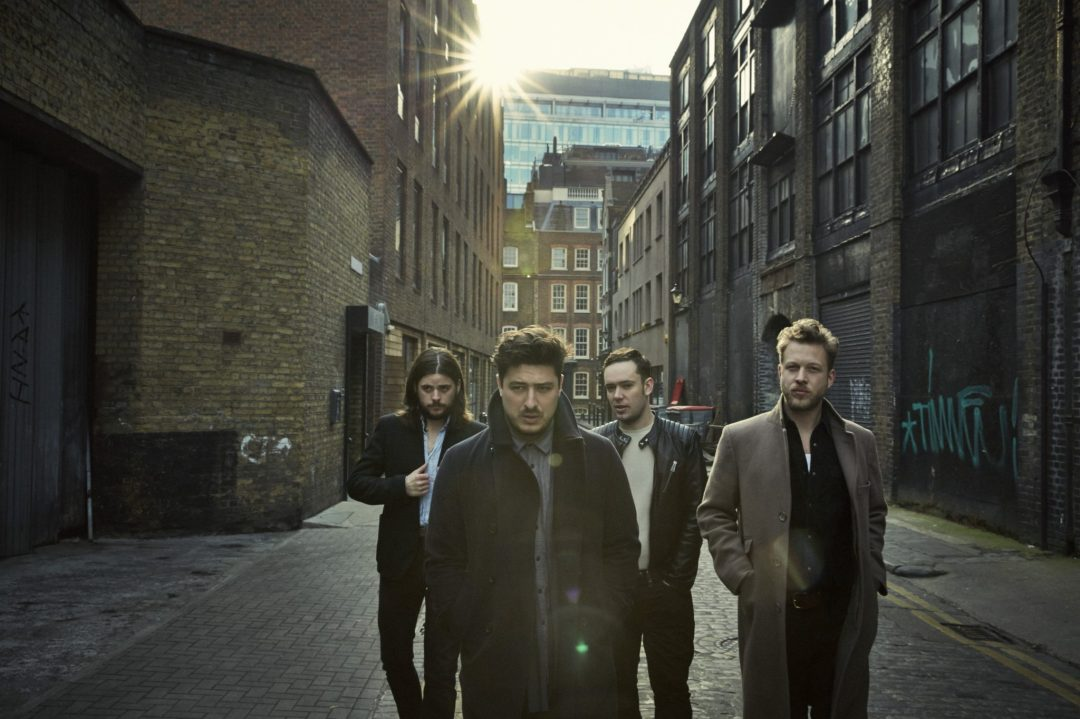What elements of the alleyway contribute to its visual appeal as a backdrop? This alleyway has a distinctive character with textures from the aged brick walls, the contrast of the dark alley against the brightness of the open sky, and graffiti adding a splash of color and urban authenticity. The sunlight breaking through adds dynamic lighting, creating a play of shadows and highlights that enhances the atmospheric quality of the setting. 